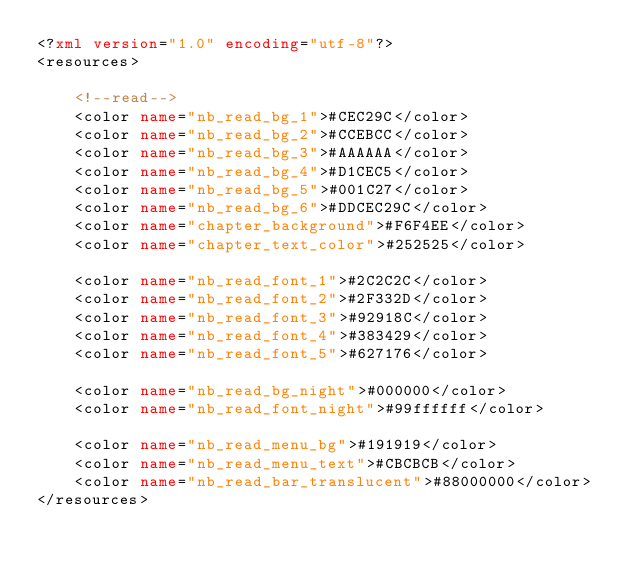<code> <loc_0><loc_0><loc_500><loc_500><_XML_><?xml version="1.0" encoding="utf-8"?>
<resources>

    <!--read-->
    <color name="nb_read_bg_1">#CEC29C</color>
    <color name="nb_read_bg_2">#CCEBCC</color>
    <color name="nb_read_bg_3">#AAAAAA</color>
    <color name="nb_read_bg_4">#D1CEC5</color>
    <color name="nb_read_bg_5">#001C27</color>
    <color name="nb_read_bg_6">#DDCEC29C</color>
    <color name="chapter_background">#F6F4EE</color>
    <color name="chapter_text_color">#252525</color>

    <color name="nb_read_font_1">#2C2C2C</color>
    <color name="nb_read_font_2">#2F332D</color>
    <color name="nb_read_font_3">#92918C</color>
    <color name="nb_read_font_4">#383429</color>
    <color name="nb_read_font_5">#627176</color>

    <color name="nb_read_bg_night">#000000</color>
    <color name="nb_read_font_night">#99ffffff</color>

    <color name="nb_read_menu_bg">#191919</color>
    <color name="nb_read_menu_text">#CBCBCB</color>
    <color name="nb_read_bar_translucent">#88000000</color>
</resources></code> 